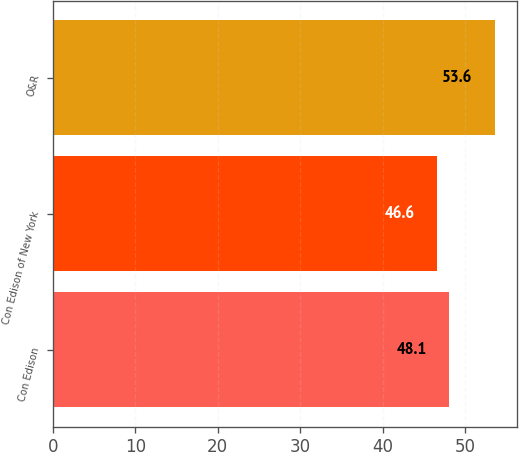Convert chart. <chart><loc_0><loc_0><loc_500><loc_500><bar_chart><fcel>Con Edison<fcel>Con Edison of New York<fcel>O&R<nl><fcel>48.1<fcel>46.6<fcel>53.6<nl></chart> 